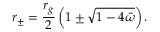Convert formula to latex. <formula><loc_0><loc_0><loc_500><loc_500>r _ { \pm } = \frac { r _ { g } } { 2 } \left ( 1 \pm \sqrt { 1 - 4 \bar { \omega } } \right ) .</formula> 